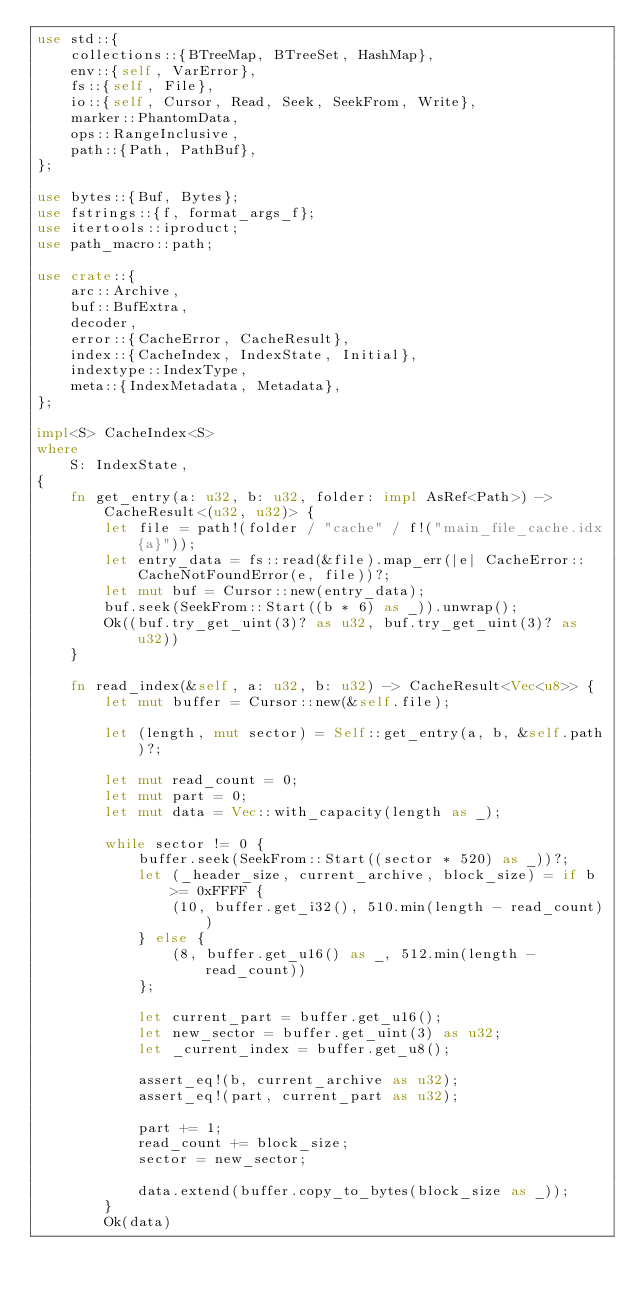<code> <loc_0><loc_0><loc_500><loc_500><_Rust_>use std::{
    collections::{BTreeMap, BTreeSet, HashMap},
    env::{self, VarError},
    fs::{self, File},
    io::{self, Cursor, Read, Seek, SeekFrom, Write},
    marker::PhantomData,
    ops::RangeInclusive,
    path::{Path, PathBuf},
};

use bytes::{Buf, Bytes};
use fstrings::{f, format_args_f};
use itertools::iproduct;
use path_macro::path;

use crate::{
    arc::Archive,
    buf::BufExtra,
    decoder,
    error::{CacheError, CacheResult},
    index::{CacheIndex, IndexState, Initial},
    indextype::IndexType,
    meta::{IndexMetadata, Metadata},
};

impl<S> CacheIndex<S>
where
    S: IndexState,
{
    fn get_entry(a: u32, b: u32, folder: impl AsRef<Path>) -> CacheResult<(u32, u32)> {
        let file = path!(folder / "cache" / f!("main_file_cache.idx{a}"));
        let entry_data = fs::read(&file).map_err(|e| CacheError::CacheNotFoundError(e, file))?;
        let mut buf = Cursor::new(entry_data);
        buf.seek(SeekFrom::Start((b * 6) as _)).unwrap();
        Ok((buf.try_get_uint(3)? as u32, buf.try_get_uint(3)? as u32))
    }

    fn read_index(&self, a: u32, b: u32) -> CacheResult<Vec<u8>> {
        let mut buffer = Cursor::new(&self.file);

        let (length, mut sector) = Self::get_entry(a, b, &self.path)?;

        let mut read_count = 0;
        let mut part = 0;
        let mut data = Vec::with_capacity(length as _);

        while sector != 0 {
            buffer.seek(SeekFrom::Start((sector * 520) as _))?;
            let (_header_size, current_archive, block_size) = if b >= 0xFFFF {
                (10, buffer.get_i32(), 510.min(length - read_count))
            } else {
                (8, buffer.get_u16() as _, 512.min(length - read_count))
            };

            let current_part = buffer.get_u16();
            let new_sector = buffer.get_uint(3) as u32;
            let _current_index = buffer.get_u8();

            assert_eq!(b, current_archive as u32);
            assert_eq!(part, current_part as u32);

            part += 1;
            read_count += block_size;
            sector = new_sector;

            data.extend(buffer.copy_to_bytes(block_size as _));
        }
        Ok(data)</code> 